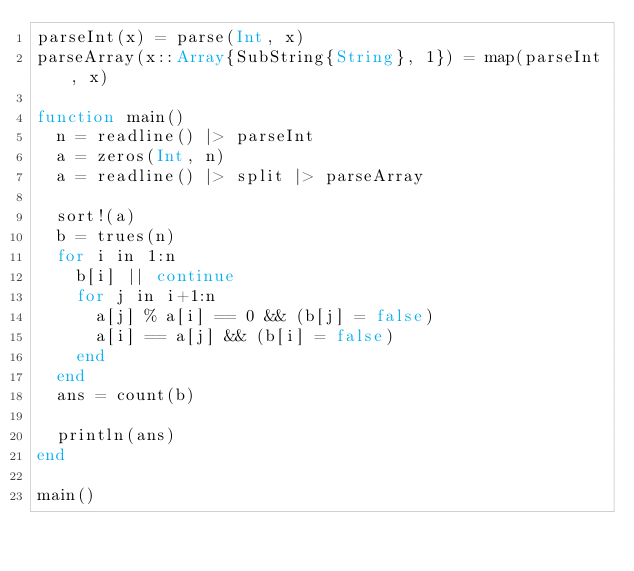Convert code to text. <code><loc_0><loc_0><loc_500><loc_500><_Julia_>parseInt(x) = parse(Int, x)
parseArray(x::Array{SubString{String}, 1}) = map(parseInt, x)

function main()
  n = readline() |> parseInt
  a = zeros(Int, n)
  a = readline() |> split |> parseArray

  sort!(a)
  b = trues(n)
  for i in 1:n
    b[i] || continue
    for j in i+1:n
      a[j] % a[i] == 0 && (b[j] = false)
      a[i] == a[j] && (b[i] = false)
    end
  end
  ans = count(b)

  println(ans)
end

main()
</code> 